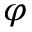Convert formula to latex. <formula><loc_0><loc_0><loc_500><loc_500>\varphi</formula> 